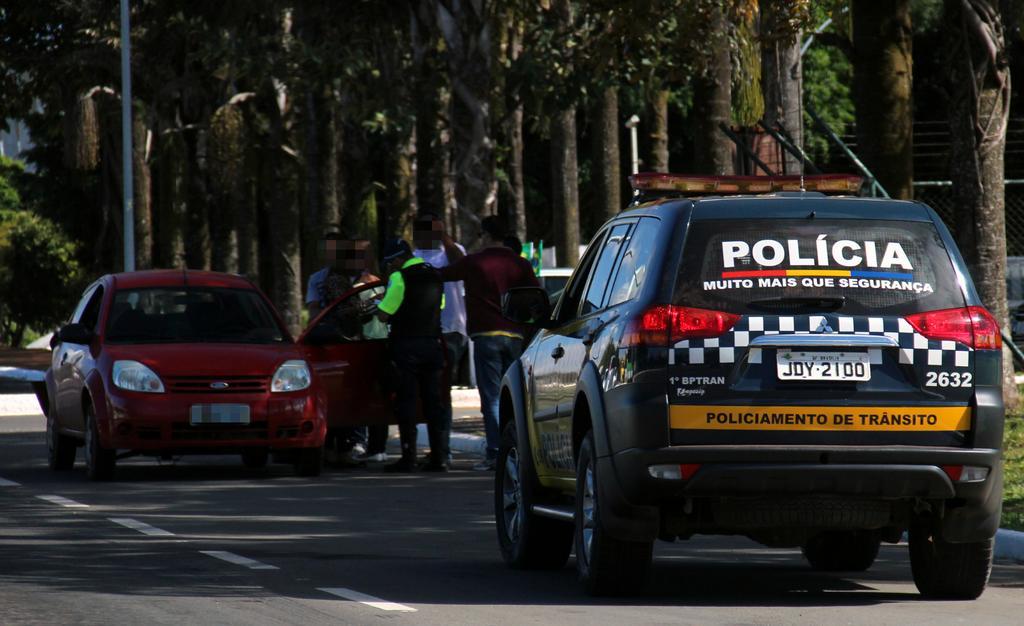Could you give a brief overview of what you see in this image? At the bottom of the image there is a road and we can see cars on the road. In the center there are people standing. In the background there are trees and a pole. 